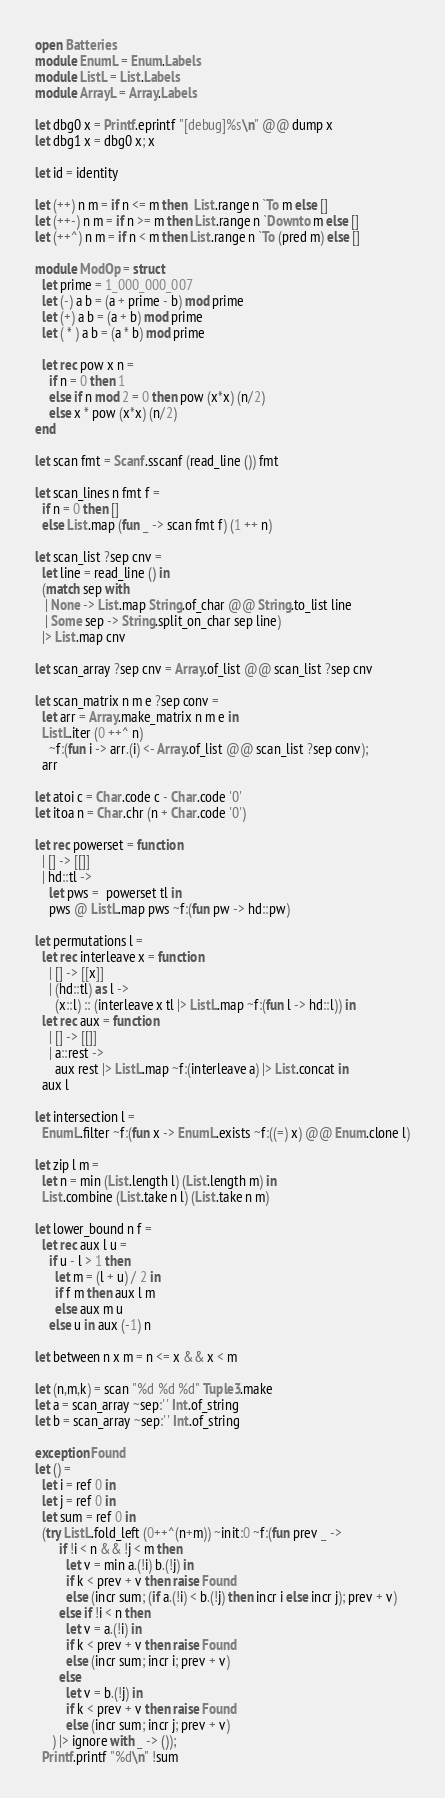Convert code to text. <code><loc_0><loc_0><loc_500><loc_500><_OCaml_>open Batteries
module EnumL = Enum.Labels
module ListL = List.Labels
module ArrayL = Array.Labels

let dbg0 x = Printf.eprintf "[debug]%s\n" @@ dump x
let dbg1 x = dbg0 x; x

let id = identity

let (++) n m = if n <= m then  List.range n `To m else []
let (++-) n m = if n >= m then List.range n `Downto m else []
let (++^) n m = if n < m then List.range n `To (pred m) else []

module ModOp = struct
  let prime = 1_000_000_007
  let (-) a b = (a + prime - b) mod prime
  let (+) a b = (a + b) mod prime
  let ( * ) a b = (a * b) mod prime

  let rec pow x n =
    if n = 0 then 1
    else if n mod 2 = 0 then pow (x*x) (n/2)
    else x * pow (x*x) (n/2)
end

let scan fmt = Scanf.sscanf (read_line ()) fmt

let scan_lines n fmt f =
  if n = 0 then []
  else List.map (fun _ -> scan fmt f) (1 ++ n)

let scan_list ?sep cnv =
  let line = read_line () in
  (match sep with
   | None -> List.map String.of_char @@ String.to_list line
   | Some sep -> String.split_on_char sep line)
  |> List.map cnv

let scan_array ?sep cnv = Array.of_list @@ scan_list ?sep cnv

let scan_matrix n m e ?sep conv =
  let arr = Array.make_matrix n m e in
  ListL.iter (0 ++^ n)
    ~f:(fun i -> arr.(i) <- Array.of_list @@ scan_list ?sep conv);
  arr

let atoi c = Char.code c - Char.code '0'
let itoa n = Char.chr (n + Char.code '0')

let rec powerset = function
  | [] -> [[]]
  | hd::tl ->
    let pws =  powerset tl in
    pws @ ListL.map pws ~f:(fun pw -> hd::pw)

let permutations l =
  let rec interleave x = function
    | [] -> [[x]]
    | (hd::tl) as l ->
      (x::l) :: (interleave x tl |> ListL.map ~f:(fun l -> hd::l)) in
  let rec aux = function
    | [] -> [[]]
    | a::rest ->
      aux rest |> ListL.map ~f:(interleave a) |> List.concat in
  aux l

let intersection l =
  EnumL.filter ~f:(fun x -> EnumL.exists ~f:((=) x) @@ Enum.clone l)

let zip l m =
  let n = min (List.length l) (List.length m) in
  List.combine (List.take n l) (List.take n m)

let lower_bound n f =
  let rec aux l u =
    if u - l > 1 then
      let m = (l + u) / 2 in
      if f m then aux l m
      else aux m u
    else u in aux (-1) n

let between n x m = n <= x && x < m

let (n,m,k) = scan "%d %d %d" Tuple3.make
let a = scan_array ~sep:' ' Int.of_string
let b = scan_array ~sep:' ' Int.of_string

exception Found
let () =
  let i = ref 0 in
  let j = ref 0 in
  let sum = ref 0 in
  (try ListL.fold_left (0++^(n+m)) ~init:0 ~f:(fun prev _ ->
       if !i < n && !j < m then
         let v = min a.(!i) b.(!j) in
         if k < prev + v then raise Found
         else (incr sum; (if a.(!i) < b.(!j) then incr i else incr j); prev + v)
       else if !i < n then
         let v = a.(!i) in
         if k < prev + v then raise Found
         else (incr sum; incr i; prev + v)
       else
         let v = b.(!j) in
         if k < prev + v then raise Found
         else (incr sum; incr j; prev + v)
     ) |> ignore with _ -> ());
  Printf.printf "%d\n" !sum
</code> 